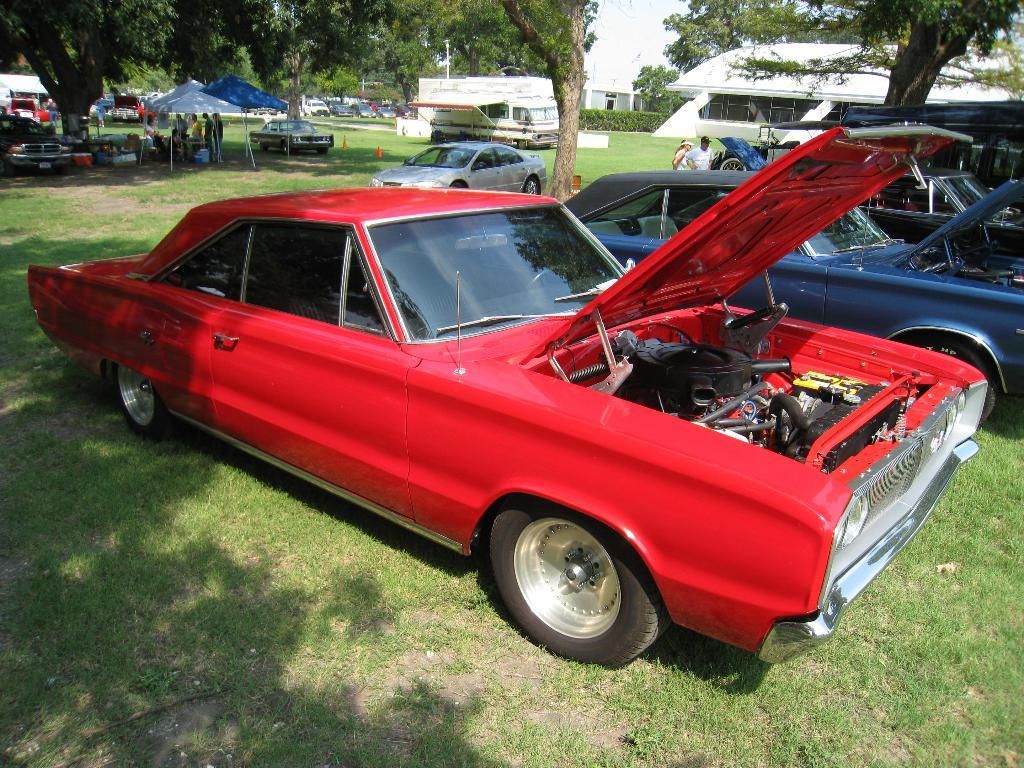What can be seen in the image involving people? There are people standing in the image. What else is present in the image besides people? There are vehicles, umbrella tents, trees, and houses in the image. Can you describe the vehicles in the image? Unfortunately, the facts provided do not give specific details about the vehicles. What type of environment is depicted in the image? The image shows a mix of natural and man-made elements, including trees and houses. What position does the crook hold in the image? There is no crook present in the image. How does the stop sign affect the flow of traffic in the image? There is no mention of a stop sign in the provided facts, so we cannot answer this question. 